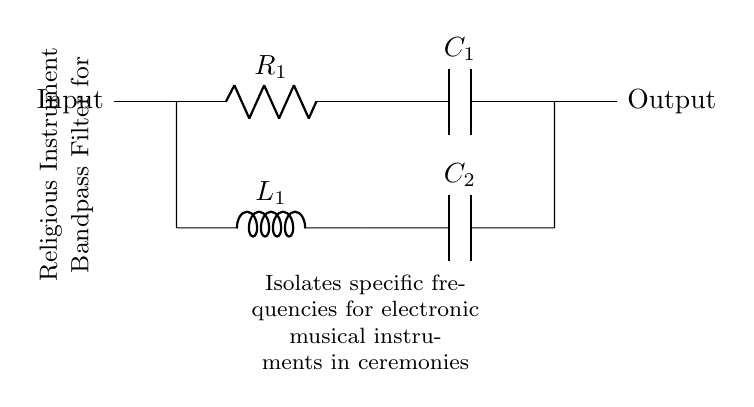What type of filter is this circuit? The circuit is a band-pass filter, as indicated by the arrangement of components that allows only a specific range of frequencies to pass through.
Answer: Band-pass filter What components are used in this circuit? The circuit consists of resistors, capacitors, and an inductor, as labeled in the diagram.
Answer: Resistor, capacitor, inductor What is the function of capacitor C1? Capacitor C1 is used to couple frequencies higher than its cutoff frequency, allowing them to pass while blocking lower frequencies.
Answer: Coupling high frequencies What is the purpose of inductor L1 in this circuit? Inductor L1 helps to block high frequencies and allows only the desired frequency range to pass through, working in conjunction with the capacitors.
Answer: Blocking high frequencies How many capacitors are in the circuit? There are two capacitors in the circuit, denoted as C1 and C2.
Answer: Two capacitors What is indicated by the input and output labels? The input label indicates where signals enter the circuit, and the output label indicates where filtered signals exit.
Answer: Signal direction Which component typically determines the lower cutoff frequency? Capacitor C2 and inductor L1 form a part of the network that sets the lower cutoff frequency of the filter.
Answer: Capacitor C2 